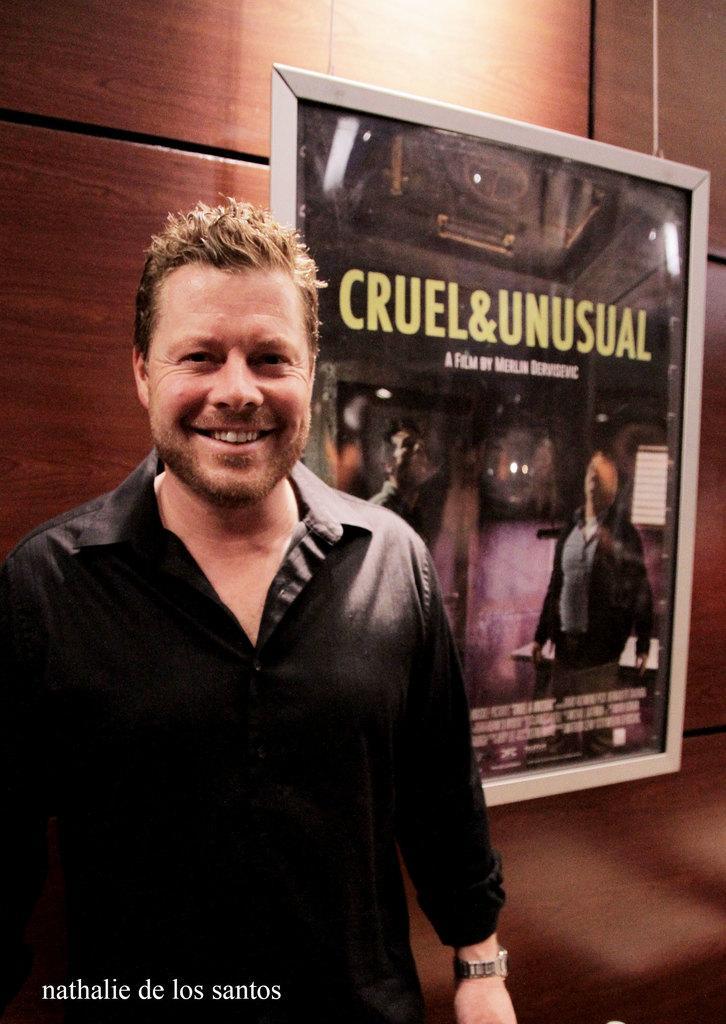Please provide a concise description of this image. In this image I can see a person is wearing black dress. Back I can see the frame and the brown wall. 